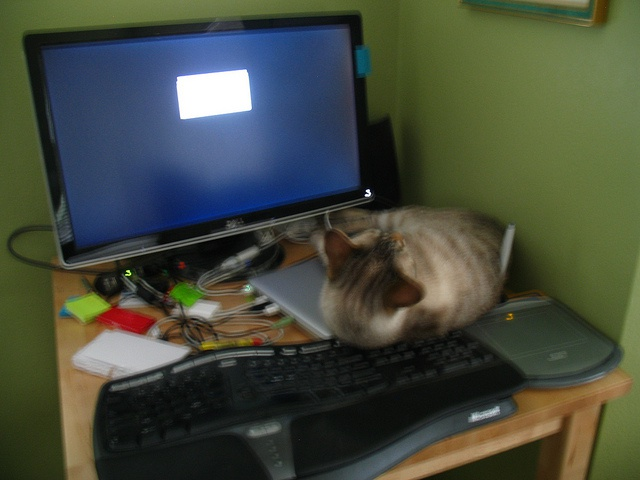Describe the objects in this image and their specific colors. I can see tv in darkgreen, navy, darkblue, black, and gray tones, keyboard in darkgreen, black, and gray tones, and cat in darkgreen, black, and gray tones in this image. 